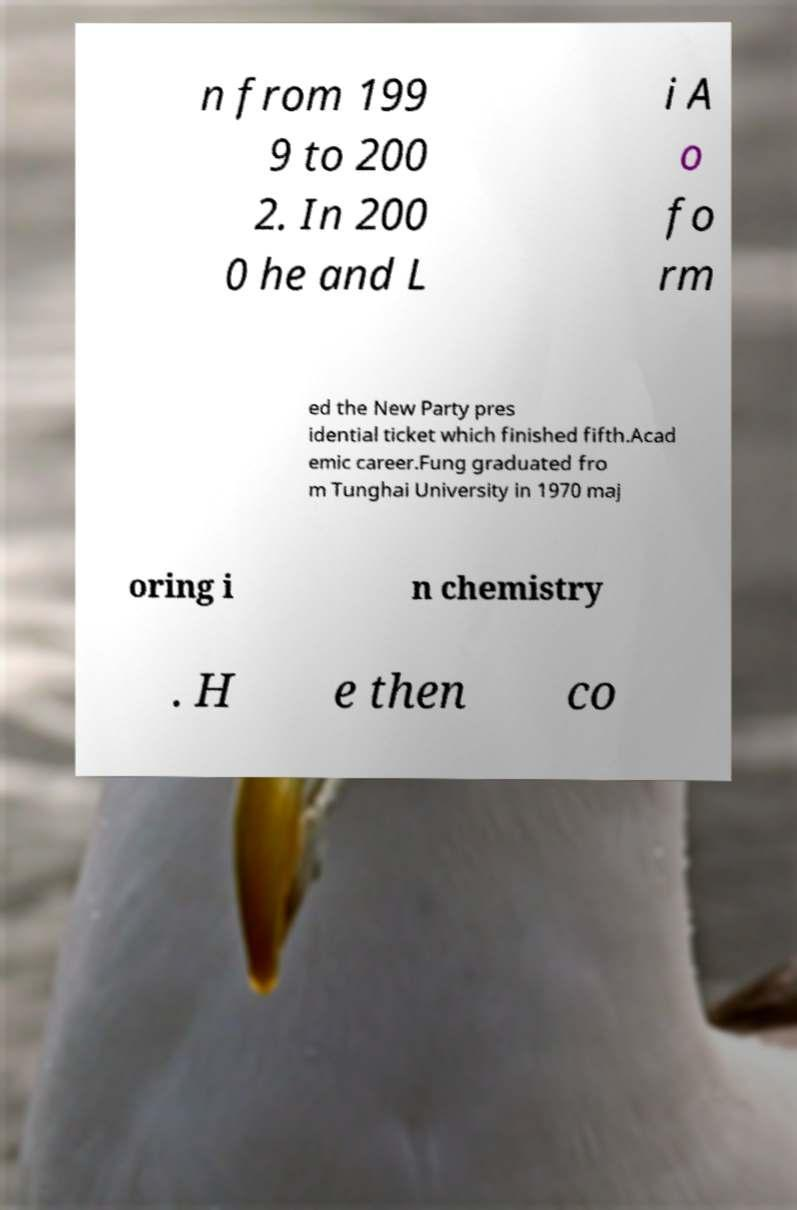Can you accurately transcribe the text from the provided image for me? n from 199 9 to 200 2. In 200 0 he and L i A o fo rm ed the New Party pres idential ticket which finished fifth.Acad emic career.Fung graduated fro m Tunghai University in 1970 maj oring i n chemistry . H e then co 